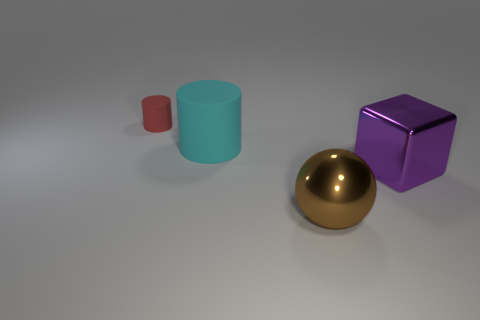Add 3 large purple blocks. How many objects exist? 7 Subtract all red cylinders. How many cylinders are left? 1 Subtract all purple balls. Subtract all purple cylinders. How many balls are left? 1 Subtract all blue blocks. How many cyan cylinders are left? 1 Subtract all small red matte things. Subtract all brown objects. How many objects are left? 2 Add 4 large blocks. How many large blocks are left? 5 Add 2 tiny brown rubber blocks. How many tiny brown rubber blocks exist? 2 Subtract 0 blue blocks. How many objects are left? 4 Subtract all blocks. How many objects are left? 3 Subtract 1 cylinders. How many cylinders are left? 1 